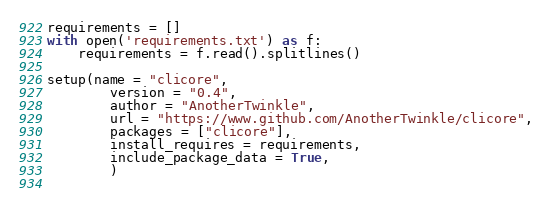Convert code to text. <code><loc_0><loc_0><loc_500><loc_500><_Python_>
requirements = []
with open('requirements.txt') as f:
    requirements = f.read().splitlines()

setup(name = "clicore",
        version = "0.4",
        author = "AnotherTwinkle",
        url = "https://www.github.com/AnotherTwinkle/clicore",
        packages = ["clicore"],
        install_requires = requirements,
        include_package_data = True,
        )
        
</code> 